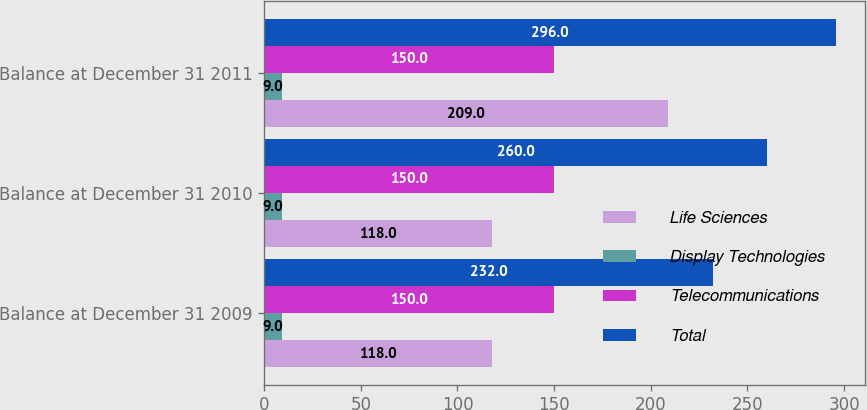Convert chart. <chart><loc_0><loc_0><loc_500><loc_500><stacked_bar_chart><ecel><fcel>Balance at December 31 2009<fcel>Balance at December 31 2010<fcel>Balance at December 31 2011<nl><fcel>Life Sciences<fcel>118<fcel>118<fcel>209<nl><fcel>Display Technologies<fcel>9<fcel>9<fcel>9<nl><fcel>Telecommunications<fcel>150<fcel>150<fcel>150<nl><fcel>Total<fcel>232<fcel>260<fcel>296<nl></chart> 